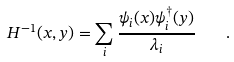<formula> <loc_0><loc_0><loc_500><loc_500>H ^ { - 1 } ( x , y ) = \sum _ { i } \frac { \psi _ { i } ( x ) \psi ^ { \dagger } _ { i } ( y ) } { \lambda _ { i } } \quad .</formula> 